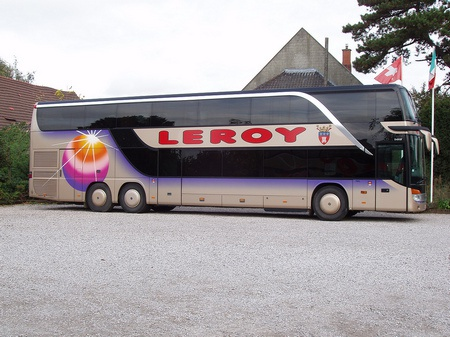Describe the objects in this image and their specific colors. I can see bus in white, black, gray, darkgray, and lightgray tones in this image. 